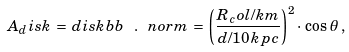Convert formula to latex. <formula><loc_0><loc_0><loc_500><loc_500>A _ { d } i s k \, = \, d i s k b b \ . \ n o r m \, = \, \left ( \frac { R _ { c } o l / k m } { d / 1 0 \, k p c } \right ) ^ { 2 } \cdot \, \cos \, \theta \, ,</formula> 